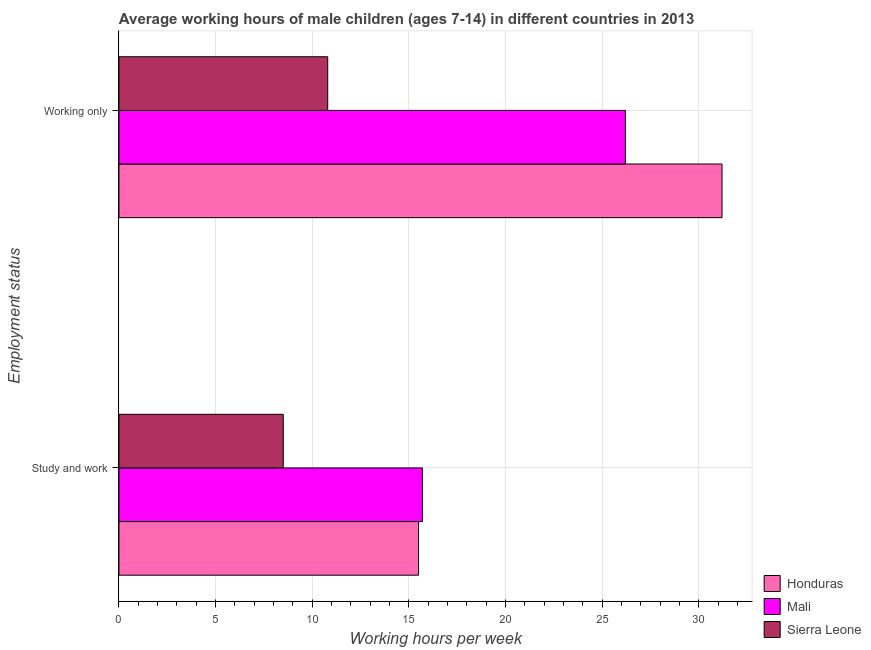Are the number of bars on each tick of the Y-axis equal?
Offer a terse response. Yes. What is the label of the 1st group of bars from the top?
Offer a very short reply. Working only. Across all countries, what is the maximum average working hour of children involved in only work?
Your response must be concise. 31.2. In which country was the average working hour of children involved in study and work maximum?
Offer a very short reply. Mali. In which country was the average working hour of children involved in study and work minimum?
Provide a short and direct response. Sierra Leone. What is the total average working hour of children involved in only work in the graph?
Keep it short and to the point. 68.2. What is the difference between the average working hour of children involved in only work in Honduras and the average working hour of children involved in study and work in Sierra Leone?
Make the answer very short. 22.7. What is the average average working hour of children involved in only work per country?
Give a very brief answer. 22.73. What is the difference between the average working hour of children involved in study and work and average working hour of children involved in only work in Honduras?
Keep it short and to the point. -15.7. In how many countries, is the average working hour of children involved in only work greater than 18 hours?
Your response must be concise. 2. What is the ratio of the average working hour of children involved in only work in Mali to that in Sierra Leone?
Ensure brevity in your answer.  2.43. In how many countries, is the average working hour of children involved in only work greater than the average average working hour of children involved in only work taken over all countries?
Offer a terse response. 2. What does the 3rd bar from the top in Working only represents?
Your response must be concise. Honduras. What does the 3rd bar from the bottom in Working only represents?
Provide a short and direct response. Sierra Leone. Are all the bars in the graph horizontal?
Offer a terse response. Yes. How many countries are there in the graph?
Offer a terse response. 3. What is the difference between two consecutive major ticks on the X-axis?
Offer a very short reply. 5. Are the values on the major ticks of X-axis written in scientific E-notation?
Give a very brief answer. No. Where does the legend appear in the graph?
Offer a very short reply. Bottom right. What is the title of the graph?
Offer a very short reply. Average working hours of male children (ages 7-14) in different countries in 2013. Does "Sint Maarten (Dutch part)" appear as one of the legend labels in the graph?
Give a very brief answer. No. What is the label or title of the X-axis?
Your answer should be very brief. Working hours per week. What is the label or title of the Y-axis?
Offer a terse response. Employment status. What is the Working hours per week of Honduras in Study and work?
Provide a short and direct response. 15.5. What is the Working hours per week of Sierra Leone in Study and work?
Keep it short and to the point. 8.5. What is the Working hours per week of Honduras in Working only?
Keep it short and to the point. 31.2. What is the Working hours per week of Mali in Working only?
Your response must be concise. 26.2. Across all Employment status, what is the maximum Working hours per week in Honduras?
Make the answer very short. 31.2. Across all Employment status, what is the maximum Working hours per week in Mali?
Your answer should be compact. 26.2. Across all Employment status, what is the minimum Working hours per week in Mali?
Make the answer very short. 15.7. What is the total Working hours per week of Honduras in the graph?
Offer a terse response. 46.7. What is the total Working hours per week of Mali in the graph?
Offer a terse response. 41.9. What is the total Working hours per week of Sierra Leone in the graph?
Your answer should be compact. 19.3. What is the difference between the Working hours per week in Honduras in Study and work and that in Working only?
Your answer should be very brief. -15.7. What is the difference between the Working hours per week in Mali in Study and work and the Working hours per week in Sierra Leone in Working only?
Provide a succinct answer. 4.9. What is the average Working hours per week in Honduras per Employment status?
Provide a short and direct response. 23.35. What is the average Working hours per week in Mali per Employment status?
Make the answer very short. 20.95. What is the average Working hours per week in Sierra Leone per Employment status?
Offer a very short reply. 9.65. What is the difference between the Working hours per week of Honduras and Working hours per week of Sierra Leone in Study and work?
Your answer should be very brief. 7. What is the difference between the Working hours per week of Honduras and Working hours per week of Sierra Leone in Working only?
Make the answer very short. 20.4. What is the difference between the Working hours per week of Mali and Working hours per week of Sierra Leone in Working only?
Provide a succinct answer. 15.4. What is the ratio of the Working hours per week in Honduras in Study and work to that in Working only?
Your answer should be very brief. 0.5. What is the ratio of the Working hours per week of Mali in Study and work to that in Working only?
Provide a succinct answer. 0.6. What is the ratio of the Working hours per week in Sierra Leone in Study and work to that in Working only?
Make the answer very short. 0.79. What is the difference between the highest and the second highest Working hours per week of Mali?
Ensure brevity in your answer.  10.5. What is the difference between the highest and the second highest Working hours per week in Sierra Leone?
Make the answer very short. 2.3. What is the difference between the highest and the lowest Working hours per week of Mali?
Keep it short and to the point. 10.5. 